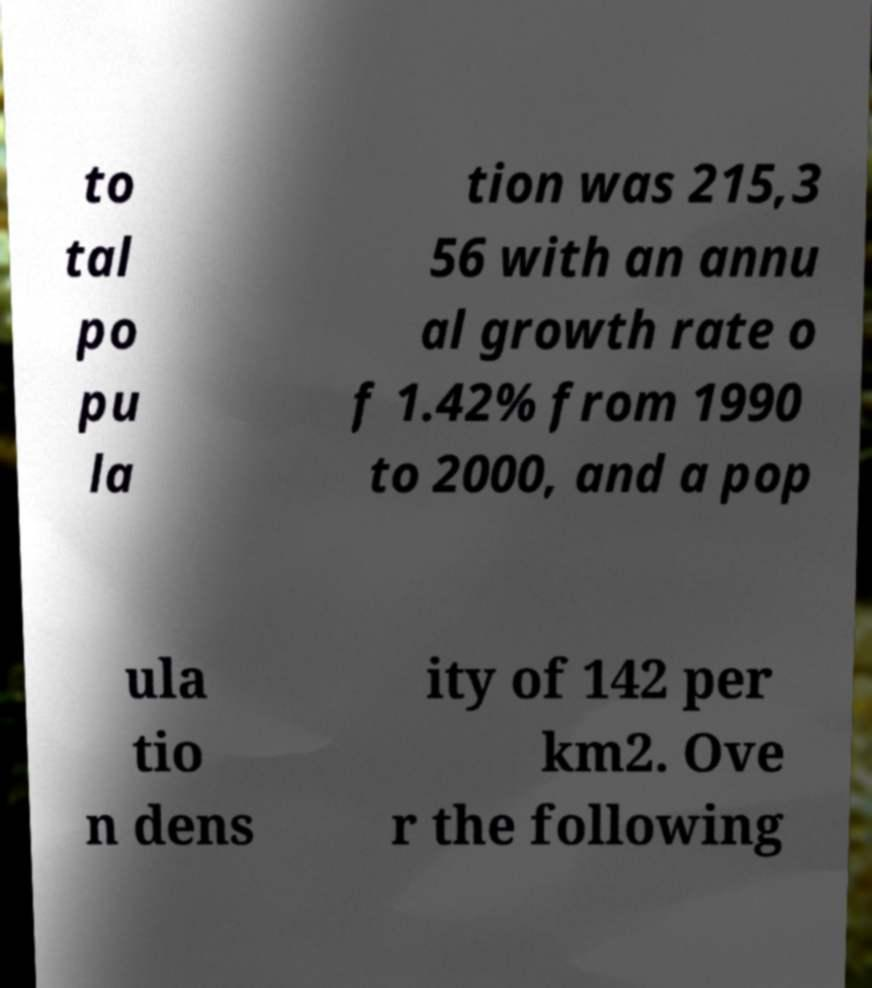Could you assist in decoding the text presented in this image and type it out clearly? to tal po pu la tion was 215,3 56 with an annu al growth rate o f 1.42% from 1990 to 2000, and a pop ula tio n dens ity of 142 per km2. Ove r the following 